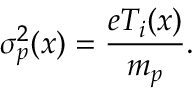<formula> <loc_0><loc_0><loc_500><loc_500>\sigma _ { p } ^ { 2 } ( x ) = \frac { e T _ { i } ( x ) } { m _ { p } } .</formula> 